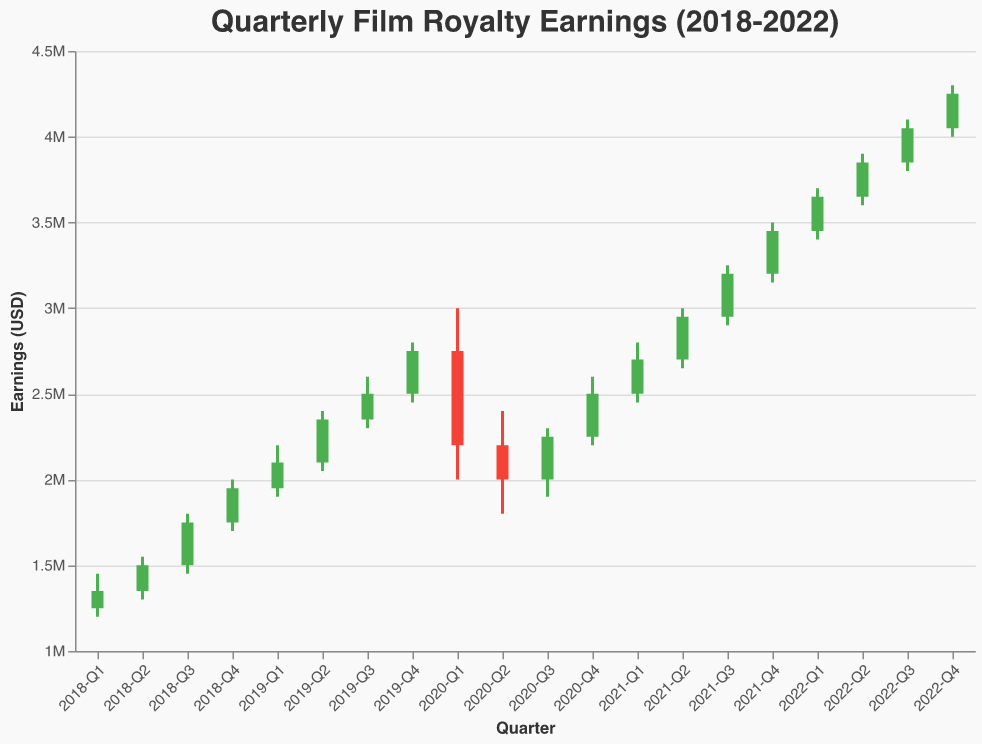What is the title of the chart? The title is the text at the top of the chart, which provides an overview of what the chart represents. The title here is "Quarterly Film Royalty Earnings (2018-2022)"
Answer: Quarterly Film Royalty Earnings (2018-2022) What does the color green indicate in the chart? The green color indicates a positive change in earnings, where the closing earnings are higher than the opening earnings for that quarter.
Answer: Positive earnings Which quarter had the highest closing earnings? Look for the bar that reaches the highest point on the y-axis among all the closing earnings. In this chart, it is "2022-Q4" with closing earnings of 4,250,000 USD.
Answer: 2022-Q4 How much did the earnings drop from 2019-Q4 to 2020-Q1? In 2019-Q4, the closing earning was 2,750,000 USD, and in 2020-Q1, it was 2,200,000 USD. The drop is calculated by subtracting the latter from the former: 2,750,000 - 2,200,000 = 550,000 USD.
Answer: 550,000 USD When did the earnings first surpass 3,000,000 USD in a quarter? Identify the first quarter where the closing earnings exceed 3,000,000 USD. This happened in "2021-Q3" with closing earnings of 3,200,000 USD.
Answer: 2021-Q3 What is the average closing earnings for the year 2019? The closing earnings for 2019 are: Q1 - 2,100,000 USD, Q2 - 2,350,000 USD, Q3 - 2,500,000 USD, Q4 - 2,750,000 USD. The average is calculated as follows: (2,100,000 + 2,350,000 + 2,500,000 + 2,750,000) / 4 = 2,425,000 USD.
Answer: 2,425,000 USD Was the lowest point of earnings during the COVID-19 pandemic? COVID-19 significantly impacted earnings in 2020. Identify the quarter with the lowest point on the chart during that year. The lowest low was 1,800,000 USD in "2020-Q2".
Answer: Yes, 2020-Q2 How did the earnings recovery look from 2020 to 2021? Examine the trend from 2020 to 2021 by comparing opening and closing points across quarters. The earnings show signs of recovery, increasing steadily after the drop in 2020, and continuing to rise throughout 2021.
Answer: Gradual recovery Which quarter had the smallest range between high and low earnings in the last five years? To determine this, find the difference between the high and low for each quarter, and identify the smallest range. "2021-Q2" had the smallest range with a difference of (3,000,000 - 2,650,000) = 350,000 USD.
Answer: 2021-Q2 